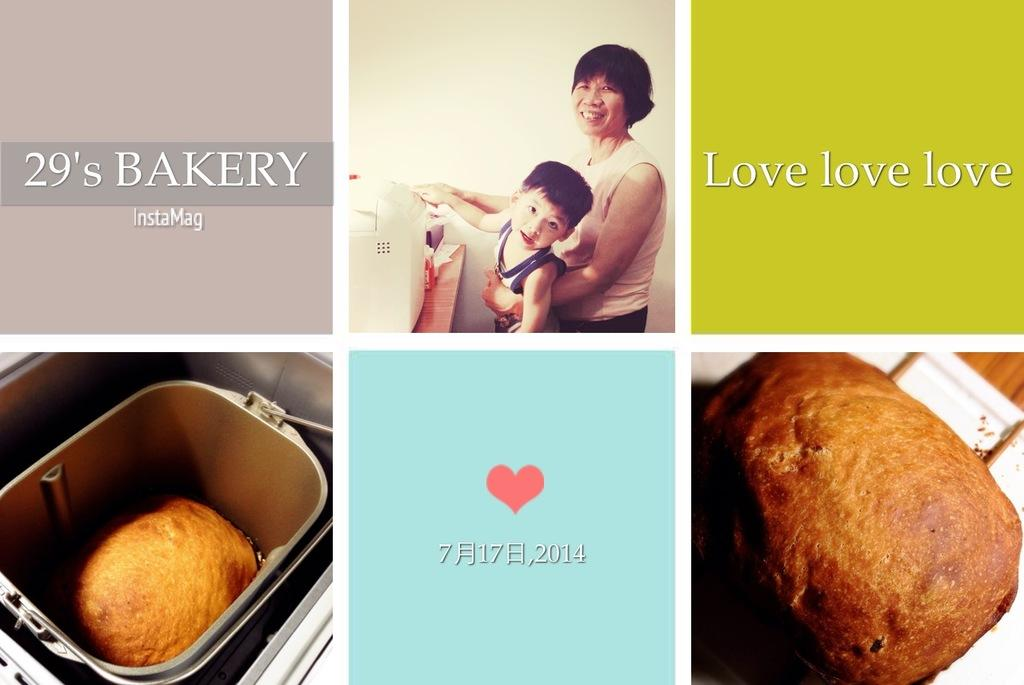<image>
Summarize the visual content of the image. a poster for 29's Bakery shows a happy mom and baby and baked goods 